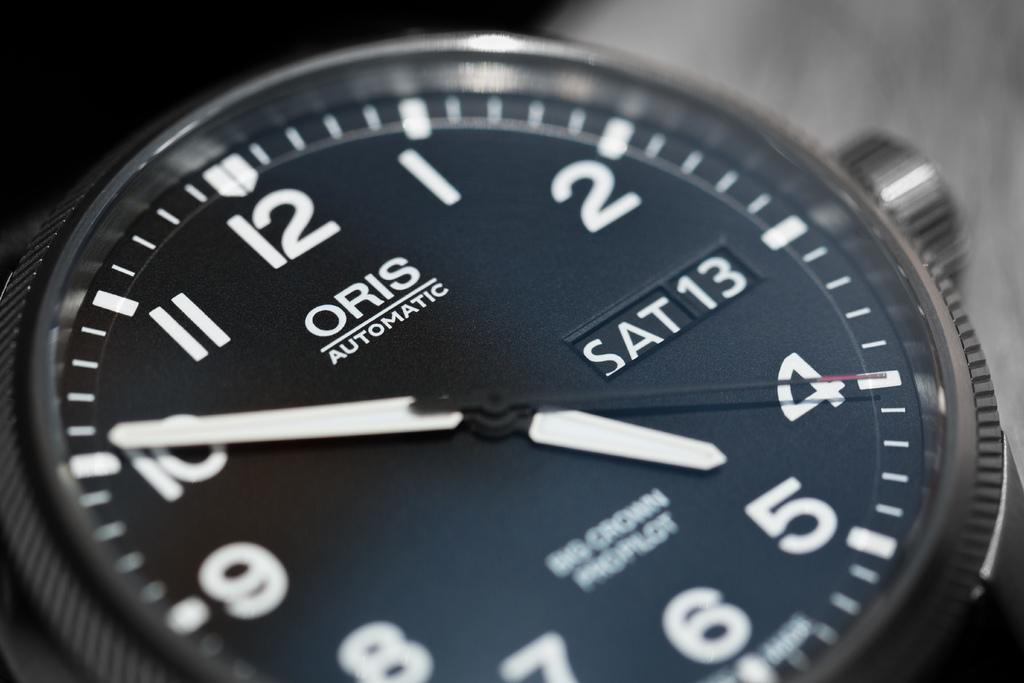What is the main subject of the image? The main subject of the image is a dial gauge of a wrist watch. Can you describe the dial gauge in more detail? The dial gauge features numbers, hands, and markings typically found on a wrist watch. How many ants are crawling on the dial gauge in the image? There are no ants present in the image; the image only features the dial gauge of a wrist watch. 